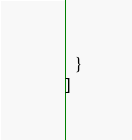Convert code to text. <code><loc_0><loc_0><loc_500><loc_500><_JavaScript_>  }
]</code> 